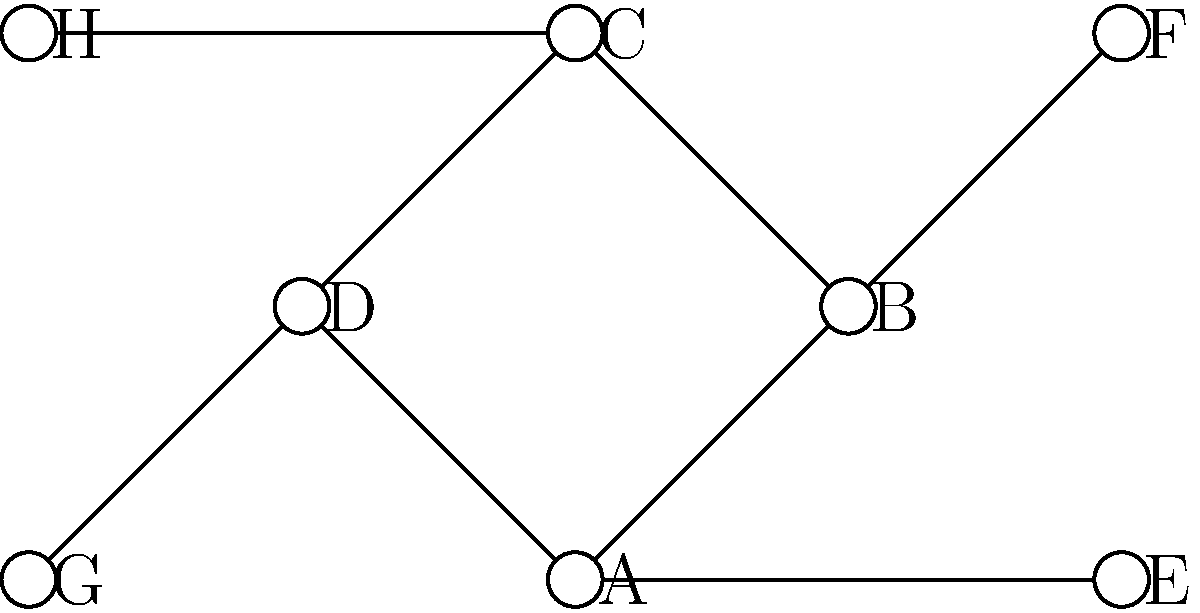In a Forró dance social event, dancers are represented as nodes in a graph, with edges connecting partners who have danced together. The graph shows the dance partnerships formed during the event. What is the degree of node B, and what does this represent in the context of the dance social? To solve this question, let's follow these steps:

1. Understand the concept of degree in graph theory:
   - The degree of a node is the number of edges connected to it.
   - In this context, it represents the number of different partners a dancer has danced with.

2. Identify node B in the graph:
   - Node B is connected to three other nodes: A, C, and F.

3. Count the number of edges connected to node B:
   - Edge B-A
   - Edge B-C
   - Edge B-F
   - Total: 3 edges

4. Interpret the meaning in the context of the Forró dance social:
   - The degree of node B is 3, which means the dancer represented by node B has danced with 3 different partners during the event.

This analysis shows how graph theory can be applied to visualize and analyze social interactions in a dance setting, which is particularly relevant for a Forró dance instructor.
Answer: 3; danced with 3 partners 